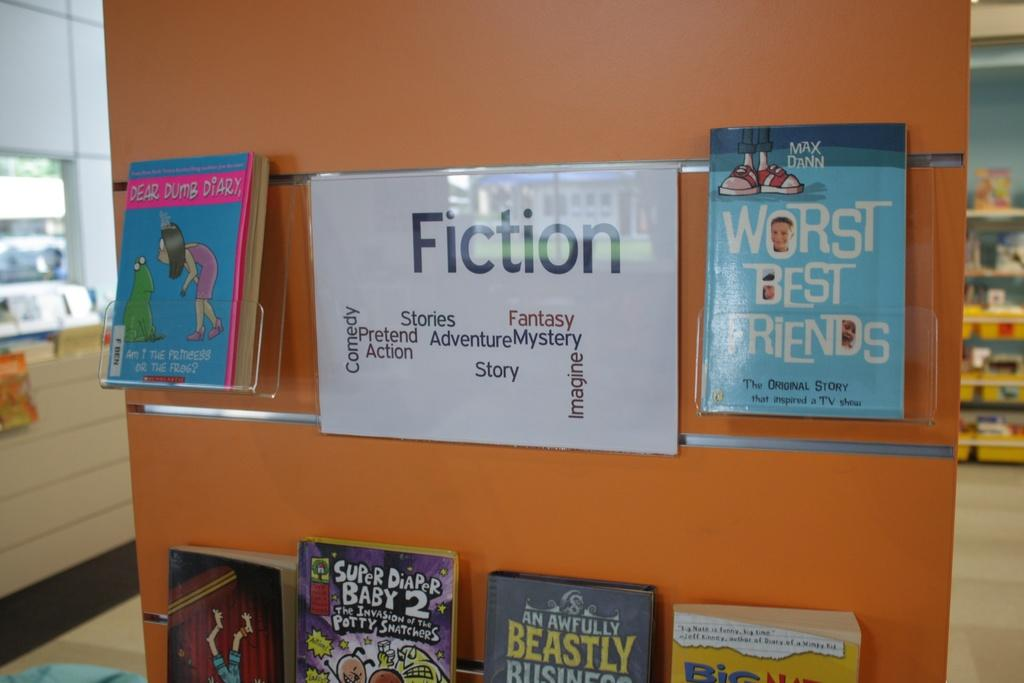<image>
Relay a brief, clear account of the picture shown. A wall displaying children's books with the label of Fiction. 